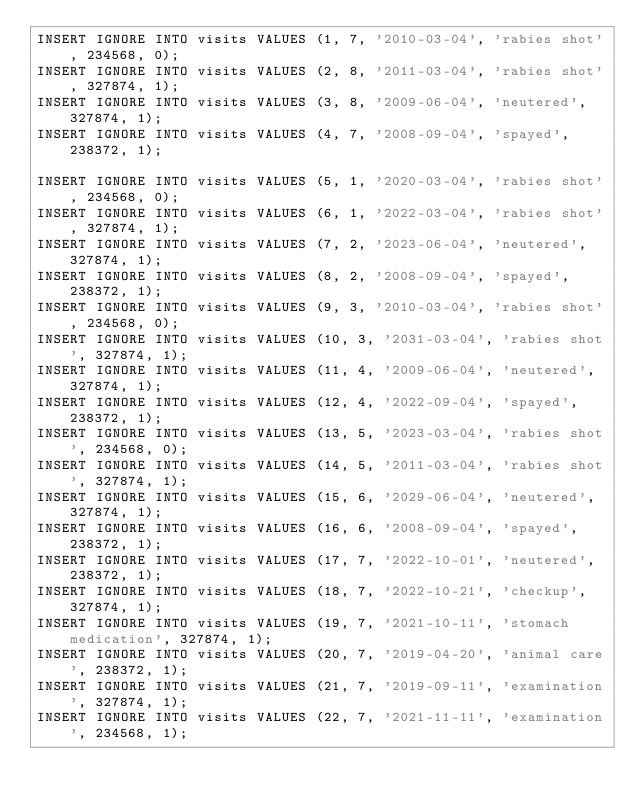<code> <loc_0><loc_0><loc_500><loc_500><_SQL_>INSERT IGNORE INTO visits VALUES (1, 7, '2010-03-04', 'rabies shot', 234568, 0);
INSERT IGNORE INTO visits VALUES (2, 8, '2011-03-04', 'rabies shot', 327874, 1);
INSERT IGNORE INTO visits VALUES (3, 8, '2009-06-04', 'neutered', 327874, 1);
INSERT IGNORE INTO visits VALUES (4, 7, '2008-09-04', 'spayed', 238372, 1);

INSERT IGNORE INTO visits VALUES (5, 1, '2020-03-04', 'rabies shot', 234568, 0);
INSERT IGNORE INTO visits VALUES (6, 1, '2022-03-04', 'rabies shot', 327874, 1);
INSERT IGNORE INTO visits VALUES (7, 2, '2023-06-04', 'neutered', 327874, 1);
INSERT IGNORE INTO visits VALUES (8, 2, '2008-09-04', 'spayed', 238372, 1);
INSERT IGNORE INTO visits VALUES (9, 3, '2010-03-04', 'rabies shot', 234568, 0);
INSERT IGNORE INTO visits VALUES (10, 3, '2031-03-04', 'rabies shot', 327874, 1);
INSERT IGNORE INTO visits VALUES (11, 4, '2009-06-04', 'neutered', 327874, 1);
INSERT IGNORE INTO visits VALUES (12, 4, '2022-09-04', 'spayed', 238372, 1);
INSERT IGNORE INTO visits VALUES (13, 5, '2023-03-04', 'rabies shot', 234568, 0);
INSERT IGNORE INTO visits VALUES (14, 5, '2011-03-04', 'rabies shot', 327874, 1);
INSERT IGNORE INTO visits VALUES (15, 6, '2029-06-04', 'neutered', 327874, 1);
INSERT IGNORE INTO visits VALUES (16, 6, '2008-09-04', 'spayed', 238372, 1);
INSERT IGNORE INTO visits VALUES (17, 7, '2022-10-01', 'neutered', 238372, 1);
INSERT IGNORE INTO visits VALUES (18, 7, '2022-10-21', 'checkup', 327874, 1);
INSERT IGNORE INTO visits VALUES (19, 7, '2021-10-11', 'stomach medication', 327874, 1);
INSERT IGNORE INTO visits VALUES (20, 7, '2019-04-20', 'animal care', 238372, 1);
INSERT IGNORE INTO visits VALUES (21, 7, '2019-09-11', 'examination', 327874, 1);
INSERT IGNORE INTO visits VALUES (22, 7, '2021-11-11', 'examination', 234568, 1);</code> 